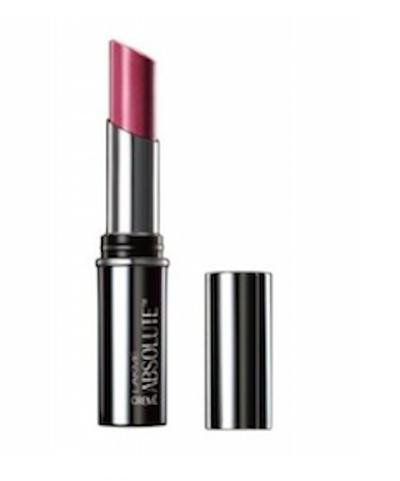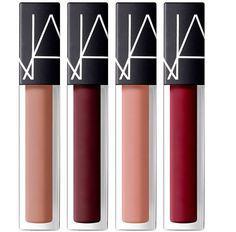The first image is the image on the left, the second image is the image on the right. Evaluate the accuracy of this statement regarding the images: "There are exactly four lipsticks in the right image.". Is it true? Answer yes or no. Yes. The first image is the image on the left, the second image is the image on the right. Assess this claim about the two images: "The lipsticks are arranged in the shape of a diamond.". Correct or not? Answer yes or no. No. The first image is the image on the left, the second image is the image on the right. For the images shown, is this caption "There are sixteen lipsticks in the right image." true? Answer yes or no. No. 